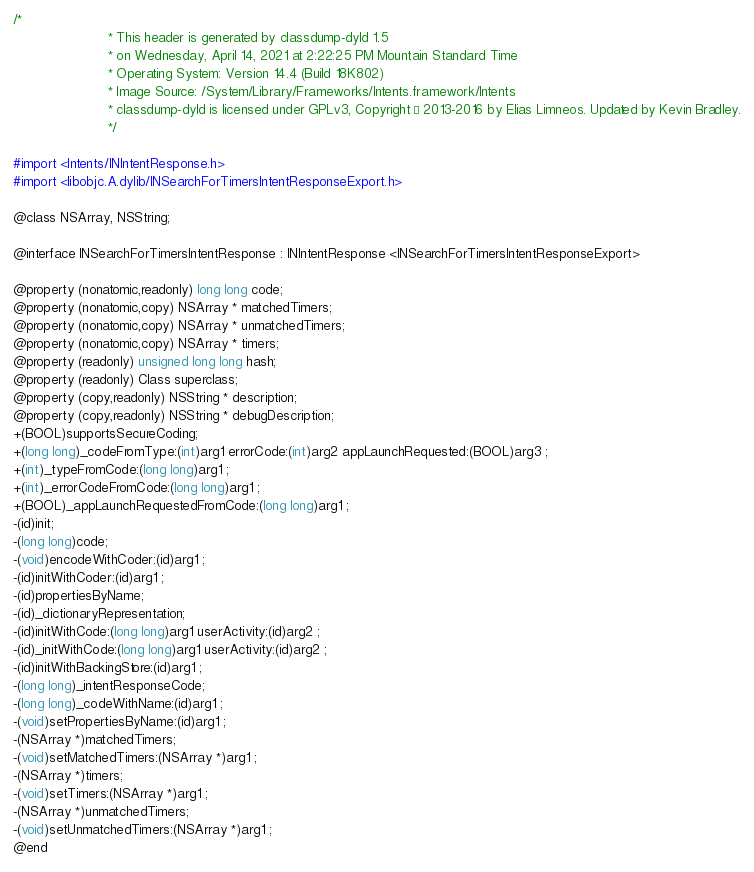Convert code to text. <code><loc_0><loc_0><loc_500><loc_500><_C_>/*
                       * This header is generated by classdump-dyld 1.5
                       * on Wednesday, April 14, 2021 at 2:22:25 PM Mountain Standard Time
                       * Operating System: Version 14.4 (Build 18K802)
                       * Image Source: /System/Library/Frameworks/Intents.framework/Intents
                       * classdump-dyld is licensed under GPLv3, Copyright © 2013-2016 by Elias Limneos. Updated by Kevin Bradley.
                       */

#import <Intents/INIntentResponse.h>
#import <libobjc.A.dylib/INSearchForTimersIntentResponseExport.h>

@class NSArray, NSString;

@interface INSearchForTimersIntentResponse : INIntentResponse <INSearchForTimersIntentResponseExport>

@property (nonatomic,readonly) long long code; 
@property (nonatomic,copy) NSArray * matchedTimers; 
@property (nonatomic,copy) NSArray * unmatchedTimers; 
@property (nonatomic,copy) NSArray * timers; 
@property (readonly) unsigned long long hash; 
@property (readonly) Class superclass; 
@property (copy,readonly) NSString * description; 
@property (copy,readonly) NSString * debugDescription; 
+(BOOL)supportsSecureCoding;
+(long long)_codeFromType:(int)arg1 errorCode:(int)arg2 appLaunchRequested:(BOOL)arg3 ;
+(int)_typeFromCode:(long long)arg1 ;
+(int)_errorCodeFromCode:(long long)arg1 ;
+(BOOL)_appLaunchRequestedFromCode:(long long)arg1 ;
-(id)init;
-(long long)code;
-(void)encodeWithCoder:(id)arg1 ;
-(id)initWithCoder:(id)arg1 ;
-(id)propertiesByName;
-(id)_dictionaryRepresentation;
-(id)initWithCode:(long long)arg1 userActivity:(id)arg2 ;
-(id)_initWithCode:(long long)arg1 userActivity:(id)arg2 ;
-(id)initWithBackingStore:(id)arg1 ;
-(long long)_intentResponseCode;
-(long long)_codeWithName:(id)arg1 ;
-(void)setPropertiesByName:(id)arg1 ;
-(NSArray *)matchedTimers;
-(void)setMatchedTimers:(NSArray *)arg1 ;
-(NSArray *)timers;
-(void)setTimers:(NSArray *)arg1 ;
-(NSArray *)unmatchedTimers;
-(void)setUnmatchedTimers:(NSArray *)arg1 ;
@end

</code> 